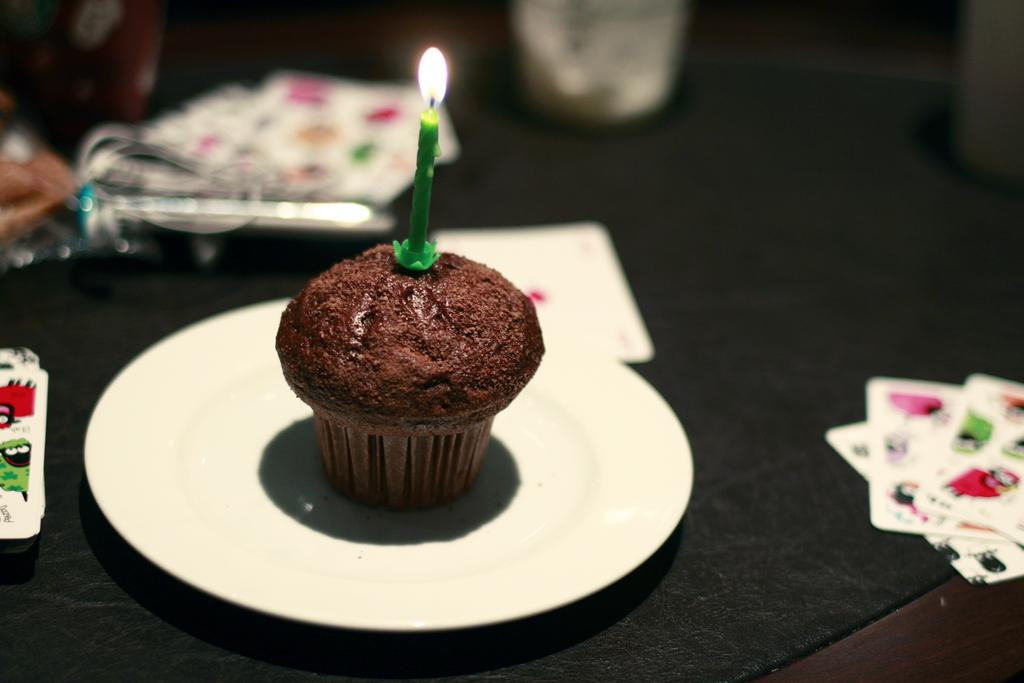What type of cake is in the image? There is a plum cake in the image. What color is the plate that the plum cake is on? The plum cake is on a white color plate. What is placed on top of the plum cake? There is a candle on the plum cake. What can be seen besides the plum cake in the image? There are cards in the image. What is the color of the surface where other objects are placed? There are other objects on a black color surface. How many mittens are placed on the plum cake? There are no mittens present in the image; only a candle is placed on the plum cake. 